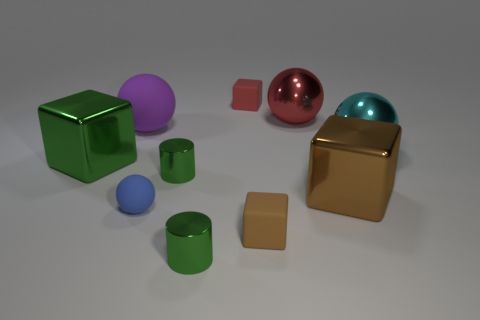What number of things are the same size as the brown metal block?
Your answer should be very brief. 4. What number of metallic objects are tiny red cubes or balls?
Make the answer very short. 2. What material is the blue sphere?
Give a very brief answer. Rubber. What number of cyan shiny balls are behind the red shiny sphere?
Give a very brief answer. 0. Do the big ball that is to the left of the small red matte object and the large green block have the same material?
Your answer should be compact. No. What number of brown matte objects are the same shape as the cyan object?
Your answer should be compact. 0. How many big objects are either cyan blocks or rubber objects?
Your response must be concise. 1. There is a tiny object that is behind the purple rubber ball; is its color the same as the small rubber ball?
Your answer should be compact. No. Does the cube that is in front of the small blue sphere have the same color as the rubber cube behind the brown rubber object?
Ensure brevity in your answer.  No. Are there any tiny gray cubes made of the same material as the large purple thing?
Your answer should be compact. No. 